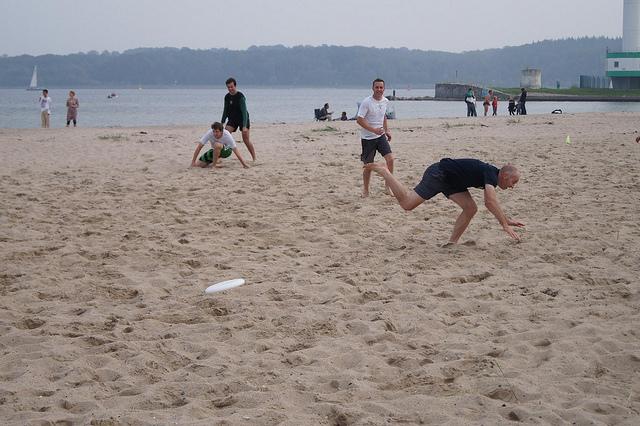Where are these people playing frisbee?
Be succinct. Beach. Are the players adults?
Quick response, please. Yes. Is there a ball suspended in the air?
Keep it brief. No. Will the man fall?
Keep it brief. Yes. How many people are over the age of 18?
Be succinct. 4. Is this a beach or a city square?
Short answer required. Beach. Why are they on a beach?
Concise answer only. Playing frisbee. 